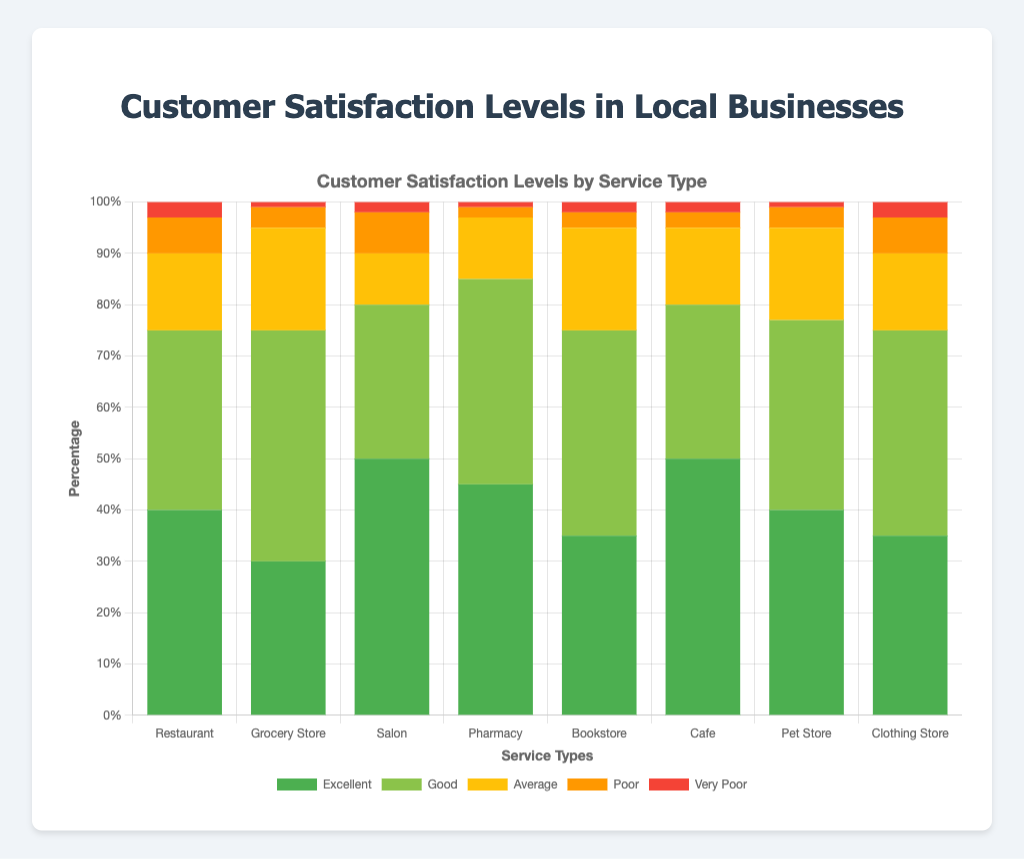Which service type has the highest percentage of "Excellent" customer satisfaction? By observing the height of the "Excellent" section of the bars, the Salon and Cafe both show the highest percentage, which is 50%.
Answer: Salon and Cafe Which service type has the lowest percentage of "Very Poor" customer satisfaction? The smallest "Very Poor" section of the bars is that of the Grocery Store and Pharmacy, both with only 1%.
Answer: Grocery Store and Pharmacy Which service type has a higher percentage of "Good" customer satisfaction: Restaurant or Clothing Store? By comparing the height of the "Good" sections for both bar charts, Restaurant has 35%, whereas Clothing Store has 40%. Therefore, the Clothing Store has a higher percentage of "Good" customer satisfaction.
Answer: Clothing Store What is the combined percentage of "Average" and "Poor" customer satisfaction for the Grocery Store? The Grocery Store has 20% "Average" and 4% "Poor" customer satisfaction. Adding these together gives 20% + 4% = 24%.
Answer: 24% Which service type has the highest percentage of "Poor" customer satisfaction, and what is that percentage? By observing the bars' "Poor" sections, the Salon has the highest percentage, which is 8%.
Answer: Salon, 8% Which service types have an equal percentage of "Excellent" and "Good" customer satisfaction? Looking at the bars, the Clothing Store has 35% "Excellent" and 40% "Good," while the percentages are not equal for any other categories. Therefore, none have equal percentages.
Answer: None Which service type has more "Excellent" customer satisfaction: Bookstore or Pet Store? By comparing the height of the "Excellent" sections of both bars, Bookstore has 35%, whereas Pet Store has 40%. Thus, Pet Store has a higher percentage of "Excellent" customer satisfaction.
Answer: Pet Store What is the total percentage of "Excellent" and "Good" customer satisfaction for the Pharmacy? The Pharmacy has 45% "Excellent" and 40% "Good". Adding these gives 45% + 40% = 85%.
Answer: 85% Which service type has the least "Average" customer satisfaction? By comparing all the "Average" sections of the bar, the Salon has the lowest percentage, which is 10%.
Answer: Salon How do the "Very Poor" customer satisfaction percentages for the Restaurant and Clothing Store compare? Both the Restaurant and Clothing Store have a "Very Poor" customer satisfaction percentage of 3%. Therefore, they are equal.
Answer: They are equal 